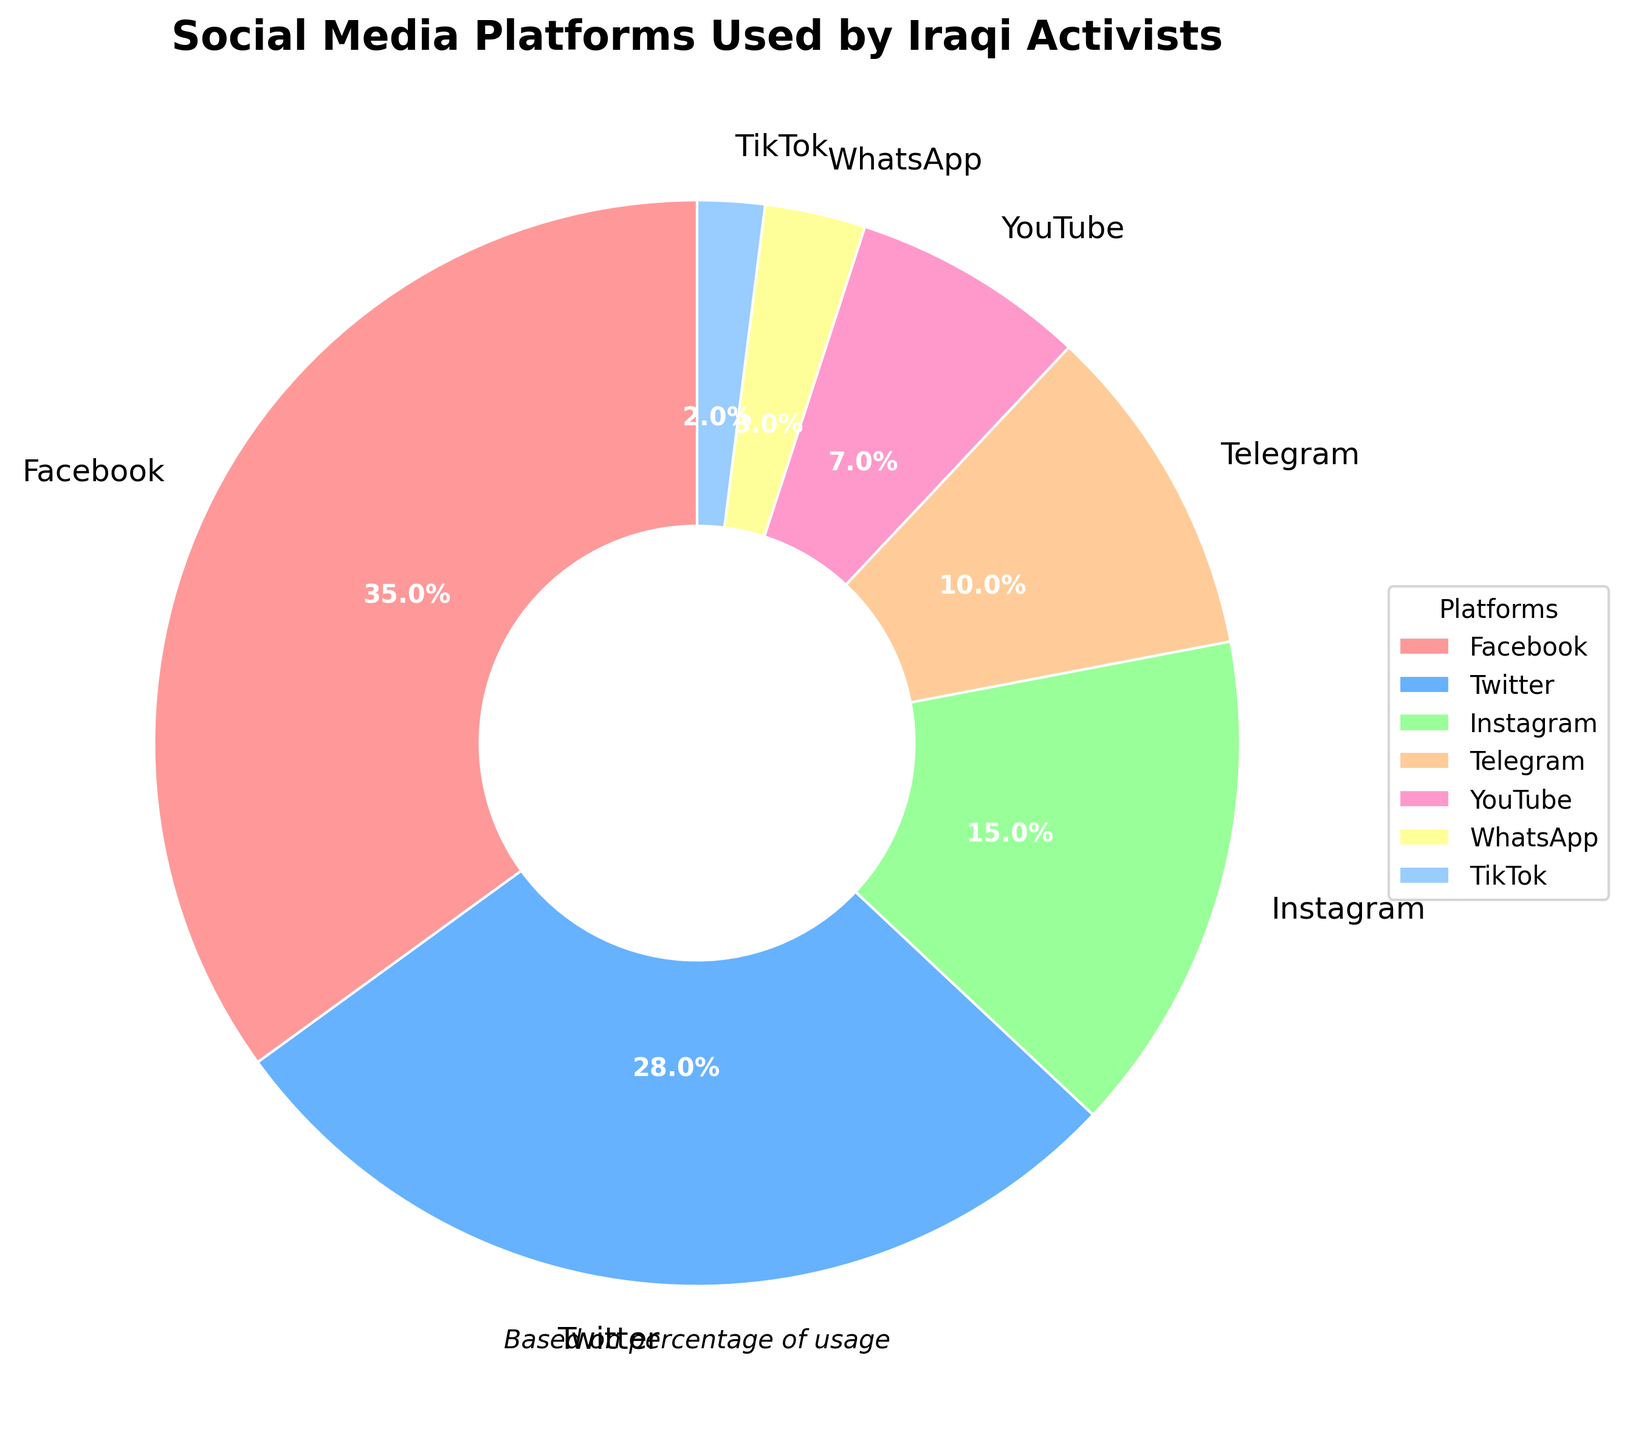What's the most widely used social media platform among Iraqi activists? The largest section of the pie chart corresponds to Facebook, which accounts for 35% of the total usage among the platforms listed.
Answer: Facebook How much more popular is Twitter than Instagram among Iraqi activists? According to the pie chart, Twitter accounts for 28% while Instagram accounts for 15%. The difference between their usage is 28% - 15% = 13%.
Answer: 13% Which platforms together make up exactly half of the total usage? The pie chart shows that Facebook makes up 35% and Twitter makes up 28%, totaling 35% + 28% = 63%. If we consider platforms that together make up 50%, Facebook (35%) and Telegram (10%) add up to 45%, while Facebook and Instagram (15%) sum to exactly 50%.
Answer: Facebook and Instagram What percentage of Iraqi activists use platforms other than Facebook and Twitter? The chart shows that 35% use Facebook and 28% use Twitter. To find the percentage for other platforms, sum their percentages: 15% (Instagram) + 10% (Telegram) + 7% (YouTube) + 3% (WhatsApp) + 2% (TikTok) = 37%.
Answer: 37% Which platform is used the least by Iraqi activists? The smallest section of the pie chart represents TikTok, which accounts for 2% of total usage.
Answer: TikTok Are more activists using Instagram or Telegram? The percentages for Instagram and Telegram are 15% and 10% respectively, so more activists use Instagram.
Answer: Instagram What is the combined usage percentage of YouTube and WhatsApp? According to the pie chart, YouTube accounts for 7% and WhatsApp accounts for 3%. Adding these together gives 7% + 3% = 10%.
Answer: 10% What is the ratio of Facebook users to TikTok users? Facebook accounts for 35% while TikTok accounts for 2%. Hence, the ratio of Facebook users to TikTok users is 35:2.
Answer: 35:2 By what percentage does Facebook usage exceed YouTube usage? Facebook usage is 35% and YouTube usage is 7%. The difference is 35% - 7% = 28%. Hence, Facebook usage exceeds YouTube usage by 28%.
Answer: 28% 